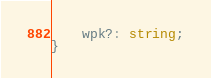Convert code to text. <code><loc_0><loc_0><loc_500><loc_500><_TypeScript_>    wpk?: string;
}
</code> 